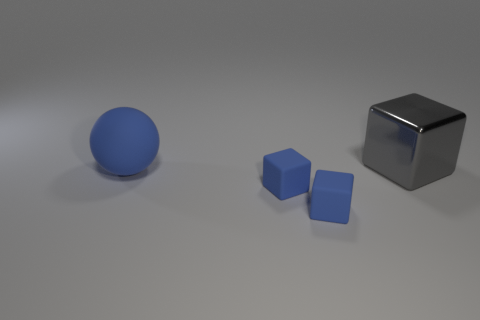How would you describe the overall composition of the objects in the image? The image presents a simple yet balanced composition with a large sphere, two cubes of different sizes, and a background that offers a neutral setting to emphasize the shapes. 